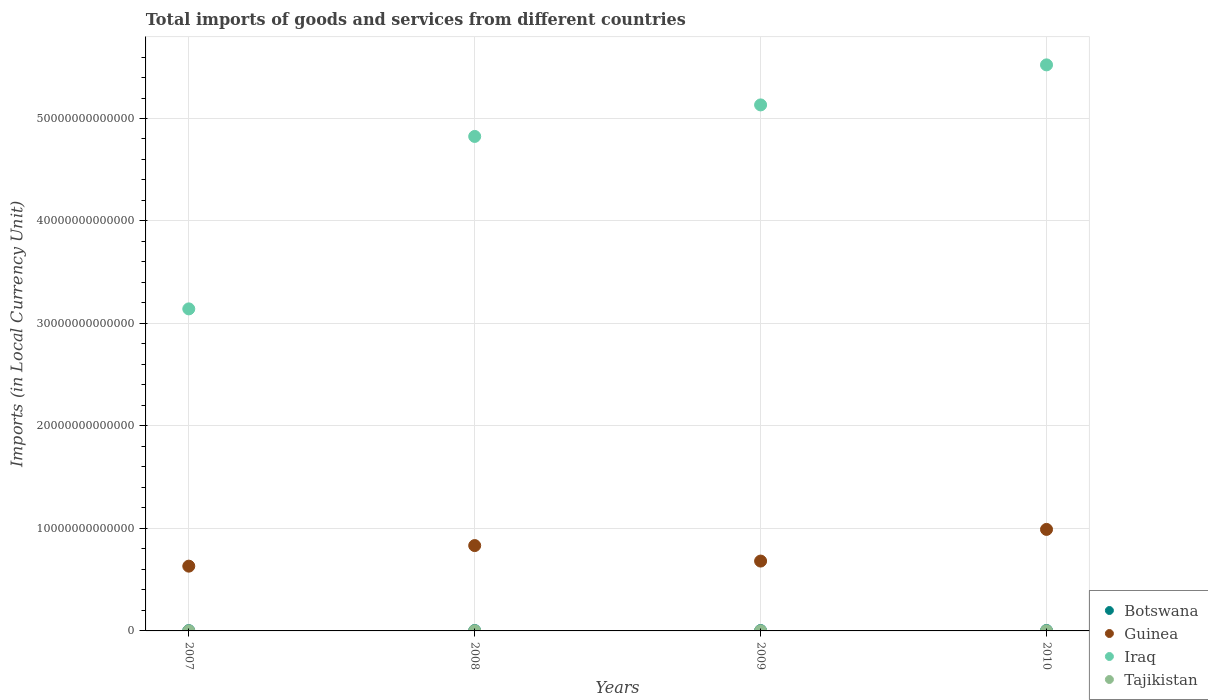How many different coloured dotlines are there?
Your response must be concise. 4. Is the number of dotlines equal to the number of legend labels?
Offer a terse response. Yes. What is the Amount of goods and services imports in Tajikistan in 2009?
Your answer should be compact. 1.12e+1. Across all years, what is the maximum Amount of goods and services imports in Botswana?
Provide a succinct answer. 4.32e+1. Across all years, what is the minimum Amount of goods and services imports in Guinea?
Offer a terse response. 6.32e+12. In which year was the Amount of goods and services imports in Botswana maximum?
Provide a short and direct response. 2010. In which year was the Amount of goods and services imports in Tajikistan minimum?
Make the answer very short. 2007. What is the total Amount of goods and services imports in Guinea in the graph?
Make the answer very short. 3.14e+13. What is the difference between the Amount of goods and services imports in Guinea in 2007 and that in 2008?
Your answer should be compact. -2.01e+12. What is the difference between the Amount of goods and services imports in Botswana in 2007 and the Amount of goods and services imports in Iraq in 2008?
Keep it short and to the point. -4.82e+13. What is the average Amount of goods and services imports in Iraq per year?
Provide a succinct answer. 4.66e+13. In the year 2007, what is the difference between the Amount of goods and services imports in Tajikistan and Amount of goods and services imports in Guinea?
Provide a short and direct response. -6.31e+12. In how many years, is the Amount of goods and services imports in Iraq greater than 12000000000000 LCU?
Your answer should be compact. 4. What is the ratio of the Amount of goods and services imports in Iraq in 2008 to that in 2009?
Your answer should be very brief. 0.94. Is the difference between the Amount of goods and services imports in Tajikistan in 2007 and 2010 greater than the difference between the Amount of goods and services imports in Guinea in 2007 and 2010?
Offer a very short reply. Yes. What is the difference between the highest and the second highest Amount of goods and services imports in Guinea?
Give a very brief answer. 1.58e+12. What is the difference between the highest and the lowest Amount of goods and services imports in Iraq?
Provide a short and direct response. 2.38e+13. Does the Amount of goods and services imports in Guinea monotonically increase over the years?
Your response must be concise. No. Is the Amount of goods and services imports in Iraq strictly less than the Amount of goods and services imports in Guinea over the years?
Offer a terse response. No. What is the difference between two consecutive major ticks on the Y-axis?
Your answer should be very brief. 1.00e+13. Does the graph contain any zero values?
Your answer should be very brief. No. Does the graph contain grids?
Ensure brevity in your answer.  Yes. Where does the legend appear in the graph?
Make the answer very short. Bottom right. What is the title of the graph?
Offer a terse response. Total imports of goods and services from different countries. What is the label or title of the Y-axis?
Offer a very short reply. Imports (in Local Currency Unit). What is the Imports (in Local Currency Unit) of Botswana in 2007?
Ensure brevity in your answer.  2.73e+1. What is the Imports (in Local Currency Unit) of Guinea in 2007?
Ensure brevity in your answer.  6.32e+12. What is the Imports (in Local Currency Unit) of Iraq in 2007?
Your response must be concise. 3.14e+13. What is the Imports (in Local Currency Unit) in Tajikistan in 2007?
Offer a terse response. 8.79e+09. What is the Imports (in Local Currency Unit) in Botswana in 2008?
Give a very brief answer. 3.81e+1. What is the Imports (in Local Currency Unit) in Guinea in 2008?
Offer a very short reply. 8.33e+12. What is the Imports (in Local Currency Unit) of Iraq in 2008?
Offer a terse response. 4.82e+13. What is the Imports (in Local Currency Unit) in Tajikistan in 2008?
Your answer should be compact. 1.27e+1. What is the Imports (in Local Currency Unit) of Botswana in 2009?
Give a very brief answer. 3.81e+1. What is the Imports (in Local Currency Unit) in Guinea in 2009?
Provide a short and direct response. 6.82e+12. What is the Imports (in Local Currency Unit) of Iraq in 2009?
Provide a succinct answer. 5.13e+13. What is the Imports (in Local Currency Unit) of Tajikistan in 2009?
Offer a terse response. 1.12e+1. What is the Imports (in Local Currency Unit) of Botswana in 2010?
Your answer should be compact. 4.32e+1. What is the Imports (in Local Currency Unit) in Guinea in 2010?
Ensure brevity in your answer.  9.91e+12. What is the Imports (in Local Currency Unit) of Iraq in 2010?
Provide a succinct answer. 5.52e+13. What is the Imports (in Local Currency Unit) in Tajikistan in 2010?
Give a very brief answer. 1.30e+1. Across all years, what is the maximum Imports (in Local Currency Unit) of Botswana?
Keep it short and to the point. 4.32e+1. Across all years, what is the maximum Imports (in Local Currency Unit) of Guinea?
Give a very brief answer. 9.91e+12. Across all years, what is the maximum Imports (in Local Currency Unit) of Iraq?
Offer a very short reply. 5.52e+13. Across all years, what is the maximum Imports (in Local Currency Unit) of Tajikistan?
Offer a very short reply. 1.30e+1. Across all years, what is the minimum Imports (in Local Currency Unit) of Botswana?
Your response must be concise. 2.73e+1. Across all years, what is the minimum Imports (in Local Currency Unit) of Guinea?
Your answer should be compact. 6.32e+12. Across all years, what is the minimum Imports (in Local Currency Unit) in Iraq?
Offer a terse response. 3.14e+13. Across all years, what is the minimum Imports (in Local Currency Unit) in Tajikistan?
Keep it short and to the point. 8.79e+09. What is the total Imports (in Local Currency Unit) in Botswana in the graph?
Make the answer very short. 1.47e+11. What is the total Imports (in Local Currency Unit) of Guinea in the graph?
Your answer should be very brief. 3.14e+13. What is the total Imports (in Local Currency Unit) of Iraq in the graph?
Provide a short and direct response. 1.86e+14. What is the total Imports (in Local Currency Unit) in Tajikistan in the graph?
Give a very brief answer. 4.57e+1. What is the difference between the Imports (in Local Currency Unit) of Botswana in 2007 and that in 2008?
Your answer should be very brief. -1.09e+1. What is the difference between the Imports (in Local Currency Unit) in Guinea in 2007 and that in 2008?
Provide a succinct answer. -2.01e+12. What is the difference between the Imports (in Local Currency Unit) of Iraq in 2007 and that in 2008?
Your response must be concise. -1.68e+13. What is the difference between the Imports (in Local Currency Unit) of Tajikistan in 2007 and that in 2008?
Your response must be concise. -3.91e+09. What is the difference between the Imports (in Local Currency Unit) of Botswana in 2007 and that in 2009?
Your answer should be very brief. -1.09e+1. What is the difference between the Imports (in Local Currency Unit) in Guinea in 2007 and that in 2009?
Your answer should be very brief. -4.95e+11. What is the difference between the Imports (in Local Currency Unit) in Iraq in 2007 and that in 2009?
Your answer should be very brief. -1.99e+13. What is the difference between the Imports (in Local Currency Unit) in Tajikistan in 2007 and that in 2009?
Provide a succinct answer. -2.44e+09. What is the difference between the Imports (in Local Currency Unit) of Botswana in 2007 and that in 2010?
Your response must be concise. -1.59e+1. What is the difference between the Imports (in Local Currency Unit) in Guinea in 2007 and that in 2010?
Provide a short and direct response. -3.59e+12. What is the difference between the Imports (in Local Currency Unit) of Iraq in 2007 and that in 2010?
Your answer should be compact. -2.38e+13. What is the difference between the Imports (in Local Currency Unit) in Tajikistan in 2007 and that in 2010?
Provide a short and direct response. -4.20e+09. What is the difference between the Imports (in Local Currency Unit) of Botswana in 2008 and that in 2009?
Keep it short and to the point. 2.30e+07. What is the difference between the Imports (in Local Currency Unit) in Guinea in 2008 and that in 2009?
Offer a very short reply. 1.51e+12. What is the difference between the Imports (in Local Currency Unit) in Iraq in 2008 and that in 2009?
Your answer should be very brief. -3.08e+12. What is the difference between the Imports (in Local Currency Unit) of Tajikistan in 2008 and that in 2009?
Provide a short and direct response. 1.47e+09. What is the difference between the Imports (in Local Currency Unit) of Botswana in 2008 and that in 2010?
Provide a succinct answer. -5.05e+09. What is the difference between the Imports (in Local Currency Unit) of Guinea in 2008 and that in 2010?
Your answer should be compact. -1.58e+12. What is the difference between the Imports (in Local Currency Unit) in Iraq in 2008 and that in 2010?
Your response must be concise. -6.98e+12. What is the difference between the Imports (in Local Currency Unit) in Tajikistan in 2008 and that in 2010?
Your response must be concise. -2.91e+08. What is the difference between the Imports (in Local Currency Unit) of Botswana in 2009 and that in 2010?
Offer a terse response. -5.07e+09. What is the difference between the Imports (in Local Currency Unit) in Guinea in 2009 and that in 2010?
Your answer should be compact. -3.09e+12. What is the difference between the Imports (in Local Currency Unit) of Iraq in 2009 and that in 2010?
Your response must be concise. -3.91e+12. What is the difference between the Imports (in Local Currency Unit) in Tajikistan in 2009 and that in 2010?
Keep it short and to the point. -1.76e+09. What is the difference between the Imports (in Local Currency Unit) of Botswana in 2007 and the Imports (in Local Currency Unit) of Guinea in 2008?
Provide a short and direct response. -8.30e+12. What is the difference between the Imports (in Local Currency Unit) in Botswana in 2007 and the Imports (in Local Currency Unit) in Iraq in 2008?
Offer a very short reply. -4.82e+13. What is the difference between the Imports (in Local Currency Unit) of Botswana in 2007 and the Imports (in Local Currency Unit) of Tajikistan in 2008?
Offer a terse response. 1.45e+1. What is the difference between the Imports (in Local Currency Unit) in Guinea in 2007 and the Imports (in Local Currency Unit) in Iraq in 2008?
Your answer should be very brief. -4.19e+13. What is the difference between the Imports (in Local Currency Unit) in Guinea in 2007 and the Imports (in Local Currency Unit) in Tajikistan in 2008?
Provide a succinct answer. 6.31e+12. What is the difference between the Imports (in Local Currency Unit) of Iraq in 2007 and the Imports (in Local Currency Unit) of Tajikistan in 2008?
Offer a very short reply. 3.14e+13. What is the difference between the Imports (in Local Currency Unit) in Botswana in 2007 and the Imports (in Local Currency Unit) in Guinea in 2009?
Ensure brevity in your answer.  -6.79e+12. What is the difference between the Imports (in Local Currency Unit) of Botswana in 2007 and the Imports (in Local Currency Unit) of Iraq in 2009?
Offer a very short reply. -5.13e+13. What is the difference between the Imports (in Local Currency Unit) of Botswana in 2007 and the Imports (in Local Currency Unit) of Tajikistan in 2009?
Provide a succinct answer. 1.60e+1. What is the difference between the Imports (in Local Currency Unit) in Guinea in 2007 and the Imports (in Local Currency Unit) in Iraq in 2009?
Ensure brevity in your answer.  -4.50e+13. What is the difference between the Imports (in Local Currency Unit) in Guinea in 2007 and the Imports (in Local Currency Unit) in Tajikistan in 2009?
Offer a terse response. 6.31e+12. What is the difference between the Imports (in Local Currency Unit) of Iraq in 2007 and the Imports (in Local Currency Unit) of Tajikistan in 2009?
Your answer should be compact. 3.14e+13. What is the difference between the Imports (in Local Currency Unit) in Botswana in 2007 and the Imports (in Local Currency Unit) in Guinea in 2010?
Keep it short and to the point. -9.88e+12. What is the difference between the Imports (in Local Currency Unit) in Botswana in 2007 and the Imports (in Local Currency Unit) in Iraq in 2010?
Offer a terse response. -5.52e+13. What is the difference between the Imports (in Local Currency Unit) of Botswana in 2007 and the Imports (in Local Currency Unit) of Tajikistan in 2010?
Offer a terse response. 1.43e+1. What is the difference between the Imports (in Local Currency Unit) in Guinea in 2007 and the Imports (in Local Currency Unit) in Iraq in 2010?
Make the answer very short. -4.89e+13. What is the difference between the Imports (in Local Currency Unit) of Guinea in 2007 and the Imports (in Local Currency Unit) of Tajikistan in 2010?
Your answer should be compact. 6.31e+12. What is the difference between the Imports (in Local Currency Unit) in Iraq in 2007 and the Imports (in Local Currency Unit) in Tajikistan in 2010?
Your answer should be very brief. 3.14e+13. What is the difference between the Imports (in Local Currency Unit) in Botswana in 2008 and the Imports (in Local Currency Unit) in Guinea in 2009?
Offer a terse response. -6.78e+12. What is the difference between the Imports (in Local Currency Unit) in Botswana in 2008 and the Imports (in Local Currency Unit) in Iraq in 2009?
Give a very brief answer. -5.13e+13. What is the difference between the Imports (in Local Currency Unit) in Botswana in 2008 and the Imports (in Local Currency Unit) in Tajikistan in 2009?
Provide a short and direct response. 2.69e+1. What is the difference between the Imports (in Local Currency Unit) of Guinea in 2008 and the Imports (in Local Currency Unit) of Iraq in 2009?
Your answer should be compact. -4.30e+13. What is the difference between the Imports (in Local Currency Unit) in Guinea in 2008 and the Imports (in Local Currency Unit) in Tajikistan in 2009?
Your response must be concise. 8.32e+12. What is the difference between the Imports (in Local Currency Unit) in Iraq in 2008 and the Imports (in Local Currency Unit) in Tajikistan in 2009?
Provide a short and direct response. 4.82e+13. What is the difference between the Imports (in Local Currency Unit) of Botswana in 2008 and the Imports (in Local Currency Unit) of Guinea in 2010?
Your answer should be very brief. -9.87e+12. What is the difference between the Imports (in Local Currency Unit) in Botswana in 2008 and the Imports (in Local Currency Unit) in Iraq in 2010?
Offer a terse response. -5.52e+13. What is the difference between the Imports (in Local Currency Unit) of Botswana in 2008 and the Imports (in Local Currency Unit) of Tajikistan in 2010?
Make the answer very short. 2.51e+1. What is the difference between the Imports (in Local Currency Unit) in Guinea in 2008 and the Imports (in Local Currency Unit) in Iraq in 2010?
Provide a succinct answer. -4.69e+13. What is the difference between the Imports (in Local Currency Unit) of Guinea in 2008 and the Imports (in Local Currency Unit) of Tajikistan in 2010?
Your answer should be compact. 8.32e+12. What is the difference between the Imports (in Local Currency Unit) of Iraq in 2008 and the Imports (in Local Currency Unit) of Tajikistan in 2010?
Your answer should be compact. 4.82e+13. What is the difference between the Imports (in Local Currency Unit) in Botswana in 2009 and the Imports (in Local Currency Unit) in Guinea in 2010?
Give a very brief answer. -9.87e+12. What is the difference between the Imports (in Local Currency Unit) in Botswana in 2009 and the Imports (in Local Currency Unit) in Iraq in 2010?
Offer a very short reply. -5.52e+13. What is the difference between the Imports (in Local Currency Unit) of Botswana in 2009 and the Imports (in Local Currency Unit) of Tajikistan in 2010?
Offer a very short reply. 2.51e+1. What is the difference between the Imports (in Local Currency Unit) in Guinea in 2009 and the Imports (in Local Currency Unit) in Iraq in 2010?
Make the answer very short. -4.84e+13. What is the difference between the Imports (in Local Currency Unit) in Guinea in 2009 and the Imports (in Local Currency Unit) in Tajikistan in 2010?
Your answer should be very brief. 6.80e+12. What is the difference between the Imports (in Local Currency Unit) in Iraq in 2009 and the Imports (in Local Currency Unit) in Tajikistan in 2010?
Give a very brief answer. 5.13e+13. What is the average Imports (in Local Currency Unit) in Botswana per year?
Make the answer very short. 3.67e+1. What is the average Imports (in Local Currency Unit) in Guinea per year?
Keep it short and to the point. 7.84e+12. What is the average Imports (in Local Currency Unit) of Iraq per year?
Ensure brevity in your answer.  4.66e+13. What is the average Imports (in Local Currency Unit) of Tajikistan per year?
Offer a terse response. 1.14e+1. In the year 2007, what is the difference between the Imports (in Local Currency Unit) in Botswana and Imports (in Local Currency Unit) in Guinea?
Provide a succinct answer. -6.29e+12. In the year 2007, what is the difference between the Imports (in Local Currency Unit) in Botswana and Imports (in Local Currency Unit) in Iraq?
Offer a terse response. -3.14e+13. In the year 2007, what is the difference between the Imports (in Local Currency Unit) in Botswana and Imports (in Local Currency Unit) in Tajikistan?
Provide a short and direct response. 1.85e+1. In the year 2007, what is the difference between the Imports (in Local Currency Unit) of Guinea and Imports (in Local Currency Unit) of Iraq?
Provide a succinct answer. -2.51e+13. In the year 2007, what is the difference between the Imports (in Local Currency Unit) of Guinea and Imports (in Local Currency Unit) of Tajikistan?
Your answer should be very brief. 6.31e+12. In the year 2007, what is the difference between the Imports (in Local Currency Unit) of Iraq and Imports (in Local Currency Unit) of Tajikistan?
Your answer should be very brief. 3.14e+13. In the year 2008, what is the difference between the Imports (in Local Currency Unit) of Botswana and Imports (in Local Currency Unit) of Guinea?
Your answer should be compact. -8.29e+12. In the year 2008, what is the difference between the Imports (in Local Currency Unit) in Botswana and Imports (in Local Currency Unit) in Iraq?
Provide a short and direct response. -4.82e+13. In the year 2008, what is the difference between the Imports (in Local Currency Unit) of Botswana and Imports (in Local Currency Unit) of Tajikistan?
Provide a succinct answer. 2.54e+1. In the year 2008, what is the difference between the Imports (in Local Currency Unit) of Guinea and Imports (in Local Currency Unit) of Iraq?
Offer a very short reply. -3.99e+13. In the year 2008, what is the difference between the Imports (in Local Currency Unit) in Guinea and Imports (in Local Currency Unit) in Tajikistan?
Give a very brief answer. 8.32e+12. In the year 2008, what is the difference between the Imports (in Local Currency Unit) in Iraq and Imports (in Local Currency Unit) in Tajikistan?
Provide a short and direct response. 4.82e+13. In the year 2009, what is the difference between the Imports (in Local Currency Unit) of Botswana and Imports (in Local Currency Unit) of Guinea?
Ensure brevity in your answer.  -6.78e+12. In the year 2009, what is the difference between the Imports (in Local Currency Unit) of Botswana and Imports (in Local Currency Unit) of Iraq?
Your response must be concise. -5.13e+13. In the year 2009, what is the difference between the Imports (in Local Currency Unit) in Botswana and Imports (in Local Currency Unit) in Tajikistan?
Your answer should be very brief. 2.69e+1. In the year 2009, what is the difference between the Imports (in Local Currency Unit) of Guinea and Imports (in Local Currency Unit) of Iraq?
Your response must be concise. -4.45e+13. In the year 2009, what is the difference between the Imports (in Local Currency Unit) of Guinea and Imports (in Local Currency Unit) of Tajikistan?
Make the answer very short. 6.80e+12. In the year 2009, what is the difference between the Imports (in Local Currency Unit) in Iraq and Imports (in Local Currency Unit) in Tajikistan?
Ensure brevity in your answer.  5.13e+13. In the year 2010, what is the difference between the Imports (in Local Currency Unit) in Botswana and Imports (in Local Currency Unit) in Guinea?
Provide a succinct answer. -9.86e+12. In the year 2010, what is the difference between the Imports (in Local Currency Unit) in Botswana and Imports (in Local Currency Unit) in Iraq?
Ensure brevity in your answer.  -5.52e+13. In the year 2010, what is the difference between the Imports (in Local Currency Unit) in Botswana and Imports (in Local Currency Unit) in Tajikistan?
Offer a very short reply. 3.02e+1. In the year 2010, what is the difference between the Imports (in Local Currency Unit) of Guinea and Imports (in Local Currency Unit) of Iraq?
Provide a succinct answer. -4.53e+13. In the year 2010, what is the difference between the Imports (in Local Currency Unit) of Guinea and Imports (in Local Currency Unit) of Tajikistan?
Your answer should be very brief. 9.89e+12. In the year 2010, what is the difference between the Imports (in Local Currency Unit) of Iraq and Imports (in Local Currency Unit) of Tajikistan?
Your answer should be very brief. 5.52e+13. What is the ratio of the Imports (in Local Currency Unit) of Botswana in 2007 to that in 2008?
Make the answer very short. 0.71. What is the ratio of the Imports (in Local Currency Unit) in Guinea in 2007 to that in 2008?
Make the answer very short. 0.76. What is the ratio of the Imports (in Local Currency Unit) of Iraq in 2007 to that in 2008?
Keep it short and to the point. 0.65. What is the ratio of the Imports (in Local Currency Unit) of Tajikistan in 2007 to that in 2008?
Keep it short and to the point. 0.69. What is the ratio of the Imports (in Local Currency Unit) of Botswana in 2007 to that in 2009?
Your response must be concise. 0.72. What is the ratio of the Imports (in Local Currency Unit) of Guinea in 2007 to that in 2009?
Keep it short and to the point. 0.93. What is the ratio of the Imports (in Local Currency Unit) of Iraq in 2007 to that in 2009?
Offer a terse response. 0.61. What is the ratio of the Imports (in Local Currency Unit) of Tajikistan in 2007 to that in 2009?
Keep it short and to the point. 0.78. What is the ratio of the Imports (in Local Currency Unit) of Botswana in 2007 to that in 2010?
Make the answer very short. 0.63. What is the ratio of the Imports (in Local Currency Unit) of Guinea in 2007 to that in 2010?
Provide a short and direct response. 0.64. What is the ratio of the Imports (in Local Currency Unit) of Iraq in 2007 to that in 2010?
Offer a terse response. 0.57. What is the ratio of the Imports (in Local Currency Unit) in Tajikistan in 2007 to that in 2010?
Your answer should be compact. 0.68. What is the ratio of the Imports (in Local Currency Unit) of Guinea in 2008 to that in 2009?
Offer a terse response. 1.22. What is the ratio of the Imports (in Local Currency Unit) of Iraq in 2008 to that in 2009?
Keep it short and to the point. 0.94. What is the ratio of the Imports (in Local Currency Unit) in Tajikistan in 2008 to that in 2009?
Your answer should be compact. 1.13. What is the ratio of the Imports (in Local Currency Unit) in Botswana in 2008 to that in 2010?
Ensure brevity in your answer.  0.88. What is the ratio of the Imports (in Local Currency Unit) of Guinea in 2008 to that in 2010?
Offer a very short reply. 0.84. What is the ratio of the Imports (in Local Currency Unit) of Iraq in 2008 to that in 2010?
Keep it short and to the point. 0.87. What is the ratio of the Imports (in Local Currency Unit) in Tajikistan in 2008 to that in 2010?
Your answer should be very brief. 0.98. What is the ratio of the Imports (in Local Currency Unit) of Botswana in 2009 to that in 2010?
Keep it short and to the point. 0.88. What is the ratio of the Imports (in Local Currency Unit) in Guinea in 2009 to that in 2010?
Offer a terse response. 0.69. What is the ratio of the Imports (in Local Currency Unit) of Iraq in 2009 to that in 2010?
Your answer should be very brief. 0.93. What is the ratio of the Imports (in Local Currency Unit) in Tajikistan in 2009 to that in 2010?
Give a very brief answer. 0.86. What is the difference between the highest and the second highest Imports (in Local Currency Unit) of Botswana?
Provide a succinct answer. 5.05e+09. What is the difference between the highest and the second highest Imports (in Local Currency Unit) in Guinea?
Ensure brevity in your answer.  1.58e+12. What is the difference between the highest and the second highest Imports (in Local Currency Unit) of Iraq?
Provide a short and direct response. 3.91e+12. What is the difference between the highest and the second highest Imports (in Local Currency Unit) in Tajikistan?
Give a very brief answer. 2.91e+08. What is the difference between the highest and the lowest Imports (in Local Currency Unit) of Botswana?
Ensure brevity in your answer.  1.59e+1. What is the difference between the highest and the lowest Imports (in Local Currency Unit) of Guinea?
Provide a succinct answer. 3.59e+12. What is the difference between the highest and the lowest Imports (in Local Currency Unit) of Iraq?
Give a very brief answer. 2.38e+13. What is the difference between the highest and the lowest Imports (in Local Currency Unit) in Tajikistan?
Offer a very short reply. 4.20e+09. 